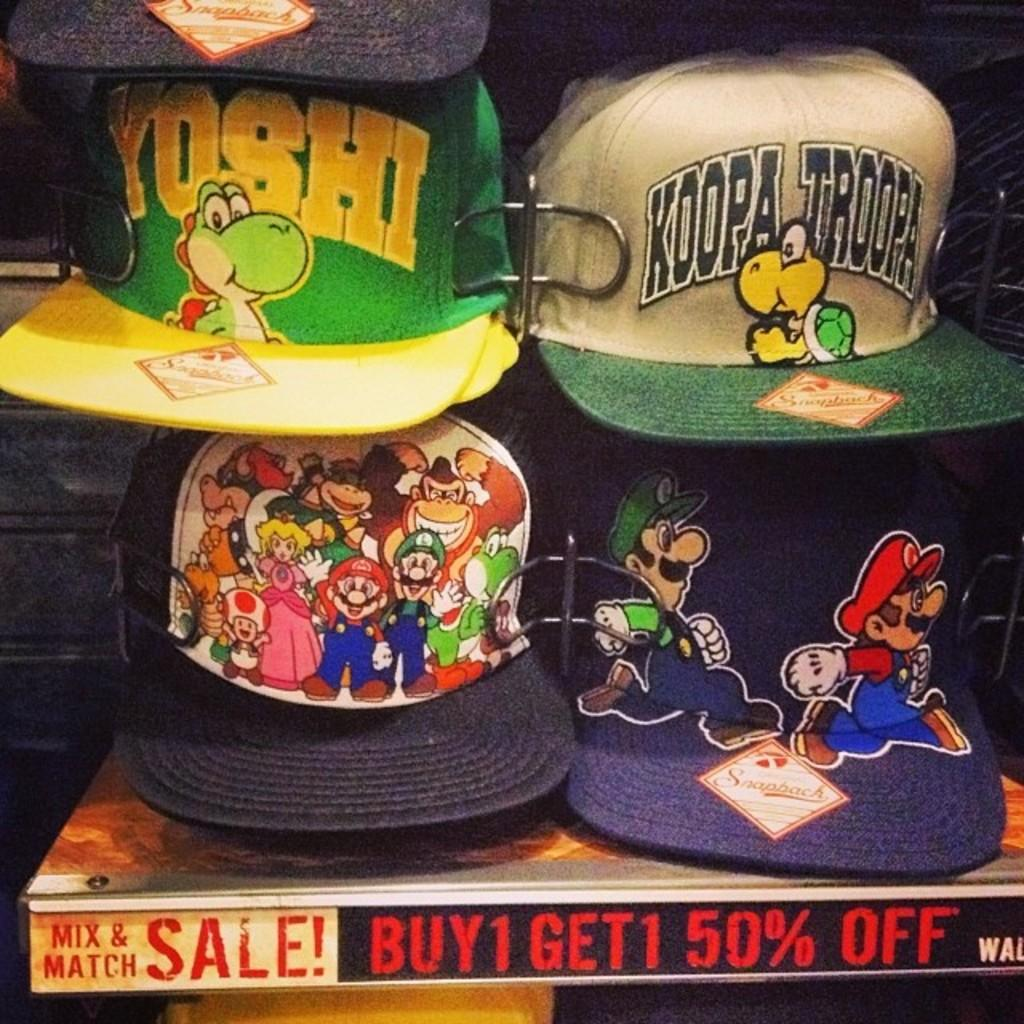What type of items are featured in the image with text and images? There are caps with text and images in the image. What is located at the bottom of the image? There is an object at the bottom of the image with some text. What material are the objects made of? The objects in the image are made of metal. What can be seen behind the items in the image? The background of the image is visible. How many horns are attached to the chickens in the image? There are no chickens or horns present in the image. What type of work are the slaves performing in the image? There is no mention of slaves or any work being performed in the image. 